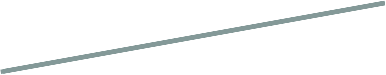<chart> <loc_0><loc_0><loc_500><loc_500><pie_chart><fcel>Effect on postretirement<nl><fcel>100.0%<nl></chart> 